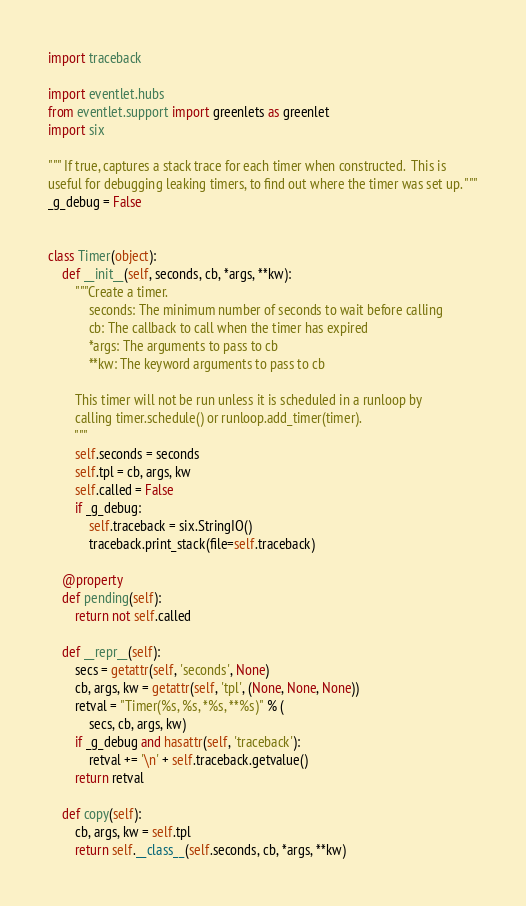Convert code to text. <code><loc_0><loc_0><loc_500><loc_500><_Python_>import traceback

import eventlet.hubs
from eventlet.support import greenlets as greenlet
import six

""" If true, captures a stack trace for each timer when constructed.  This is
useful for debugging leaking timers, to find out where the timer was set up. """
_g_debug = False


class Timer(object):
    def __init__(self, seconds, cb, *args, **kw):
        """Create a timer.
            seconds: The minimum number of seconds to wait before calling
            cb: The callback to call when the timer has expired
            *args: The arguments to pass to cb
            **kw: The keyword arguments to pass to cb

        This timer will not be run unless it is scheduled in a runloop by
        calling timer.schedule() or runloop.add_timer(timer).
        """
        self.seconds = seconds
        self.tpl = cb, args, kw
        self.called = False
        if _g_debug:
            self.traceback = six.StringIO()
            traceback.print_stack(file=self.traceback)

    @property
    def pending(self):
        return not self.called

    def __repr__(self):
        secs = getattr(self, 'seconds', None)
        cb, args, kw = getattr(self, 'tpl', (None, None, None))
        retval = "Timer(%s, %s, *%s, **%s)" % (
            secs, cb, args, kw)
        if _g_debug and hasattr(self, 'traceback'):
            retval += '\n' + self.traceback.getvalue()
        return retval

    def copy(self):
        cb, args, kw = self.tpl
        return self.__class__(self.seconds, cb, *args, **kw)
</code> 